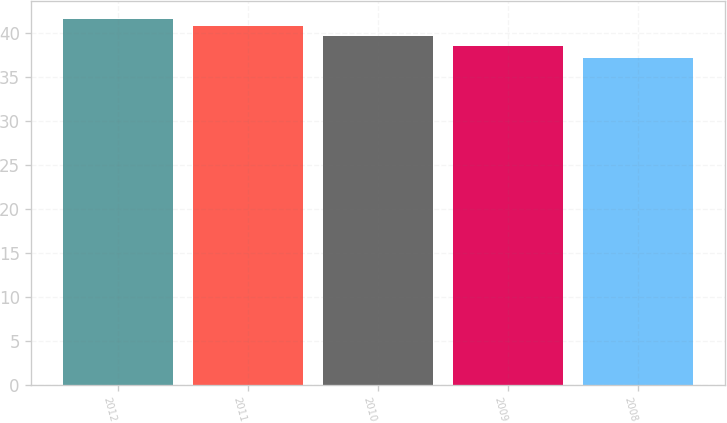Convert chart to OTSL. <chart><loc_0><loc_0><loc_500><loc_500><bar_chart><fcel>2012<fcel>2011<fcel>2010<fcel>2009<fcel>2008<nl><fcel>41.57<fcel>40.8<fcel>39.65<fcel>38.46<fcel>37.12<nl></chart> 